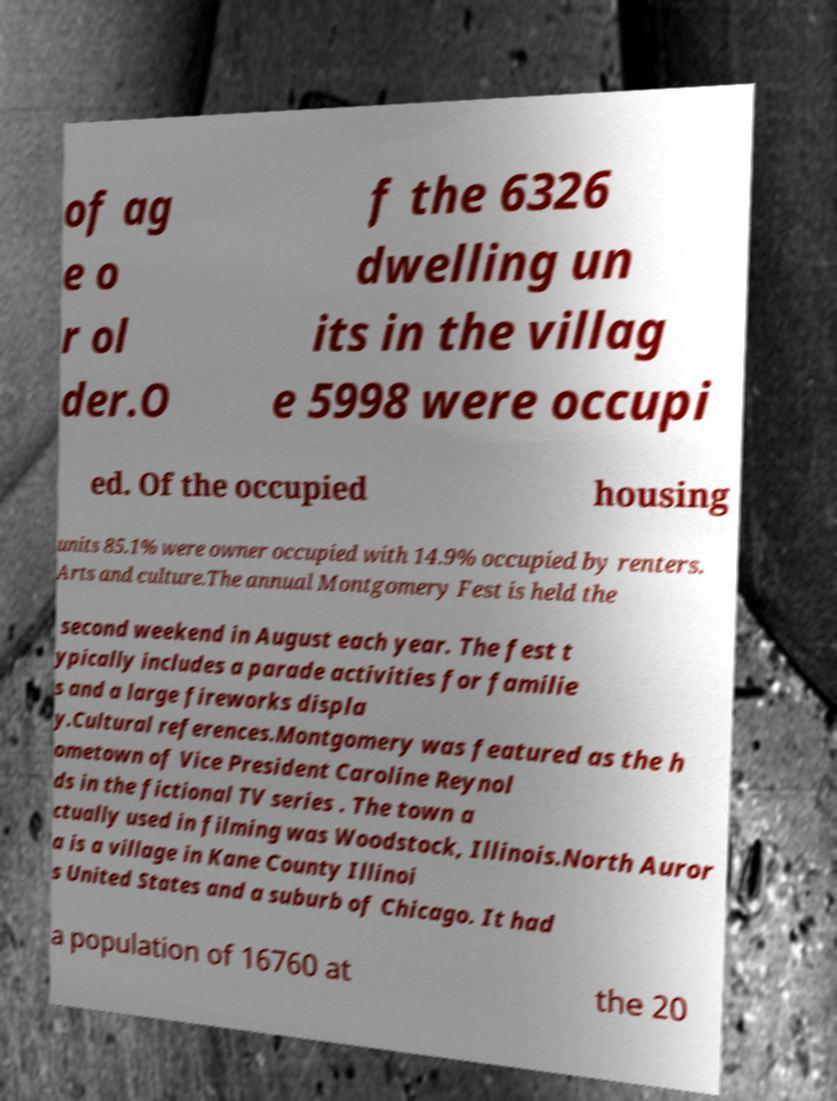I need the written content from this picture converted into text. Can you do that? of ag e o r ol der.O f the 6326 dwelling un its in the villag e 5998 were occupi ed. Of the occupied housing units 85.1% were owner occupied with 14.9% occupied by renters. Arts and culture.The annual Montgomery Fest is held the second weekend in August each year. The fest t ypically includes a parade activities for familie s and a large fireworks displa y.Cultural references.Montgomery was featured as the h ometown of Vice President Caroline Reynol ds in the fictional TV series . The town a ctually used in filming was Woodstock, Illinois.North Auror a is a village in Kane County Illinoi s United States and a suburb of Chicago. It had a population of 16760 at the 20 